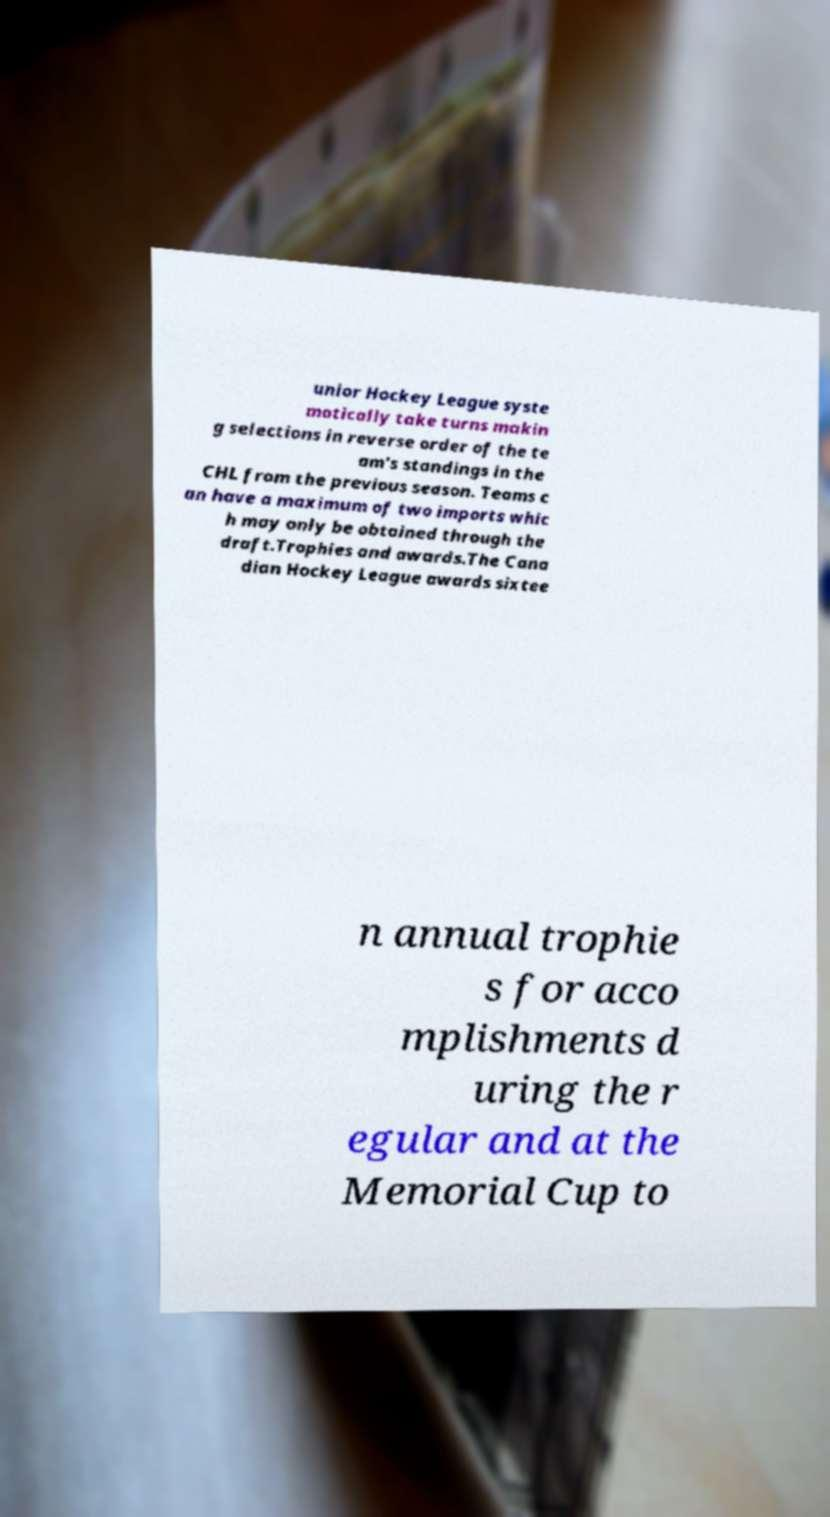For documentation purposes, I need the text within this image transcribed. Could you provide that? unior Hockey League syste matically take turns makin g selections in reverse order of the te am's standings in the CHL from the previous season. Teams c an have a maximum of two imports whic h may only be obtained through the draft.Trophies and awards.The Cana dian Hockey League awards sixtee n annual trophie s for acco mplishments d uring the r egular and at the Memorial Cup to 